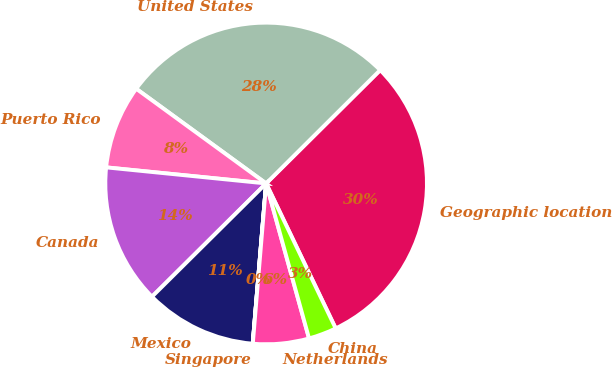Convert chart. <chart><loc_0><loc_0><loc_500><loc_500><pie_chart><fcel>Geographic location<fcel>United States<fcel>Puerto Rico<fcel>Canada<fcel>Mexico<fcel>Singapore<fcel>Netherlands<fcel>China<nl><fcel>30.33%<fcel>27.52%<fcel>8.43%<fcel>14.03%<fcel>11.23%<fcel>0.01%<fcel>5.62%<fcel>2.82%<nl></chart> 